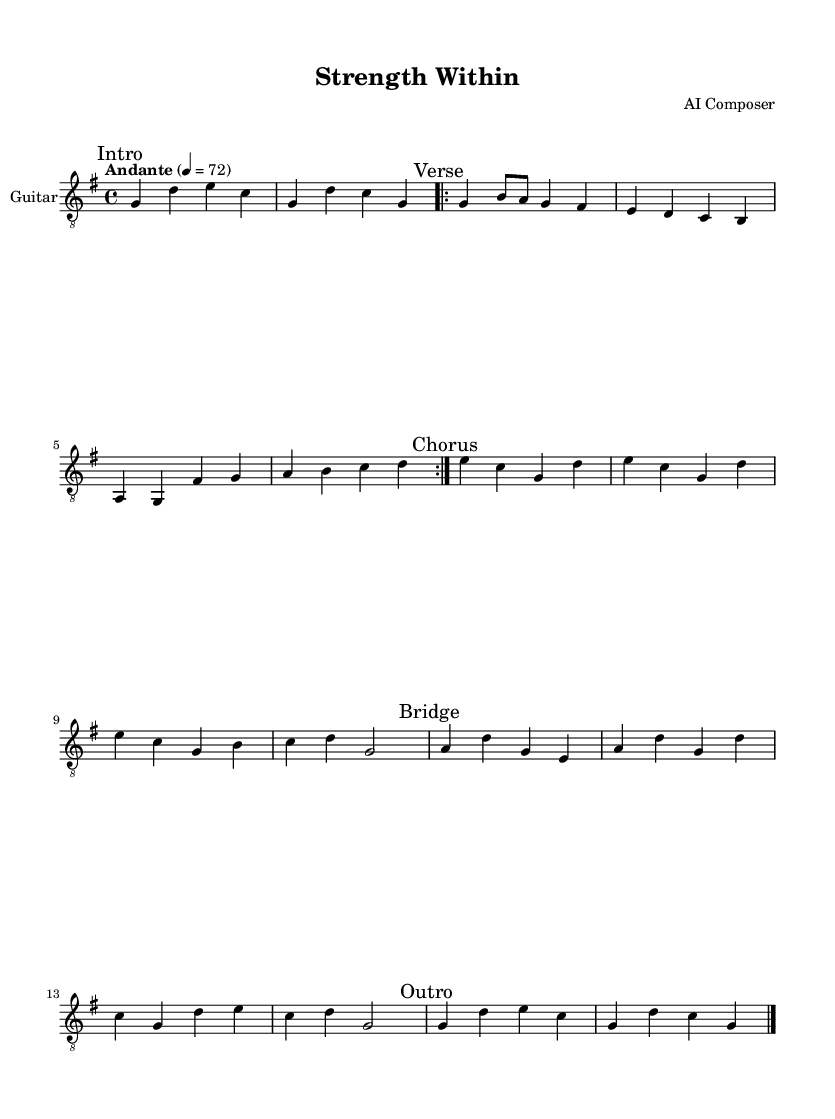What is the key signature of this music? The key signature displayed in the music indicates G major, which has one sharp (F#). This is determined by looking at the key signature marking at the beginning of the sheet music.
Answer: G major What is the time signature of this piece? The time signature shown is 4/4, meaning there are four beats in a measure and a quarter note receives one beat. This is conveyed through the notation located at the beginning of the score.
Answer: 4/4 What is the tempo marking for this piece? The tempo marking indicates "Andante," which typically signifies a moderate walking pace. You can find this marking at the start of the sheet music alongside the metronome marking of 72 beats per minute.
Answer: Andante How many sections are there in this composition? The music is divided into five sections: Intro, Verse, Chorus, Bridge, and Outro. This can be deduced from the marks indicating the start of each section throughout the sheet music.
Answer: Five What is the first note of the Chorus section? The first note of the Chorus section is E. This is determined by examining the notes in the measure that follows the "Chorus" marking.
Answer: E What pattern do you notice in the Verse section? In the Verse section, there is a repeated pattern that consists of eight notes before reaching a different part. This is evident from the "repeat volta" marking which indicates that those eight measures are played twice.
Answer: Repeated eight-note pattern Which instrument is specified for this sheet music? The specified instrument for this sheet music is the acoustic guitar (nylon), as indicated in the score where the instrument name is clearly marked.
Answer: Acoustic guitar (nylon) 